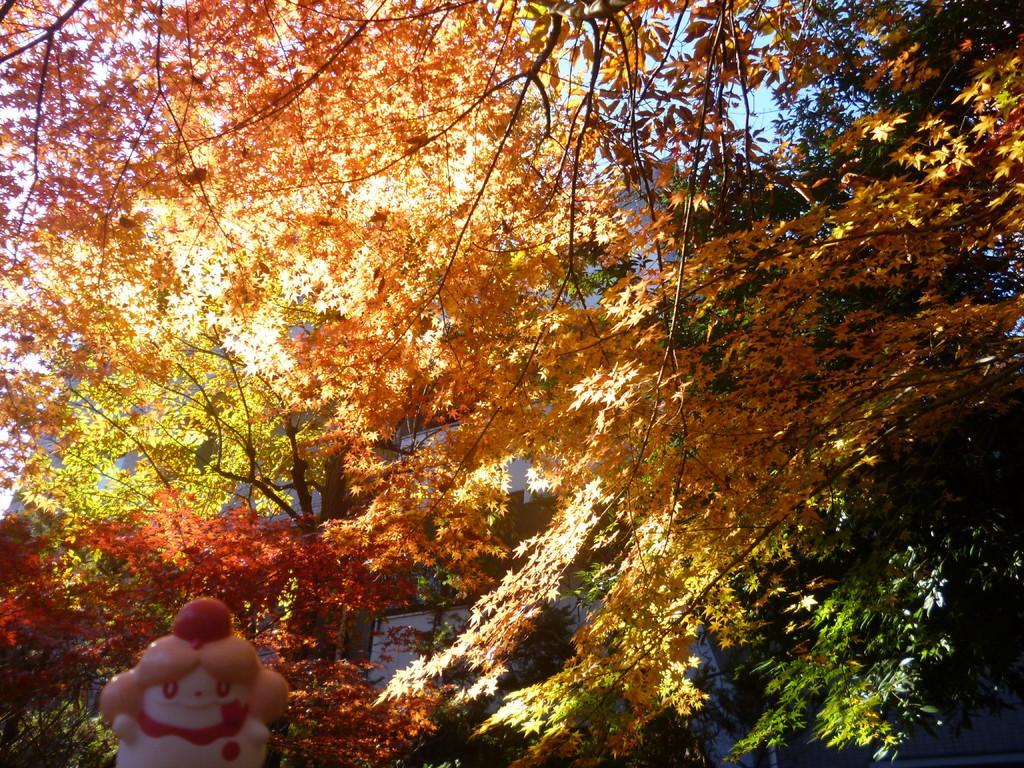What type of tree is depicted in the image? There is a colorful tree in the image. What else can be seen in the image besides the tree? There is a toy visible at the bottom of the image. How does the tree feel when you touch it in the image? The image is a static representation, so it is not possible to touch the tree or feel its texture. 